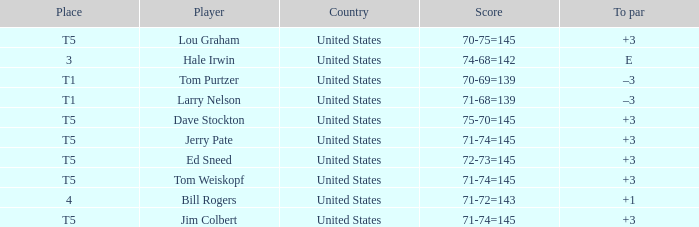What is the to par of player ed sneed, who has a t5 place? 3.0. 